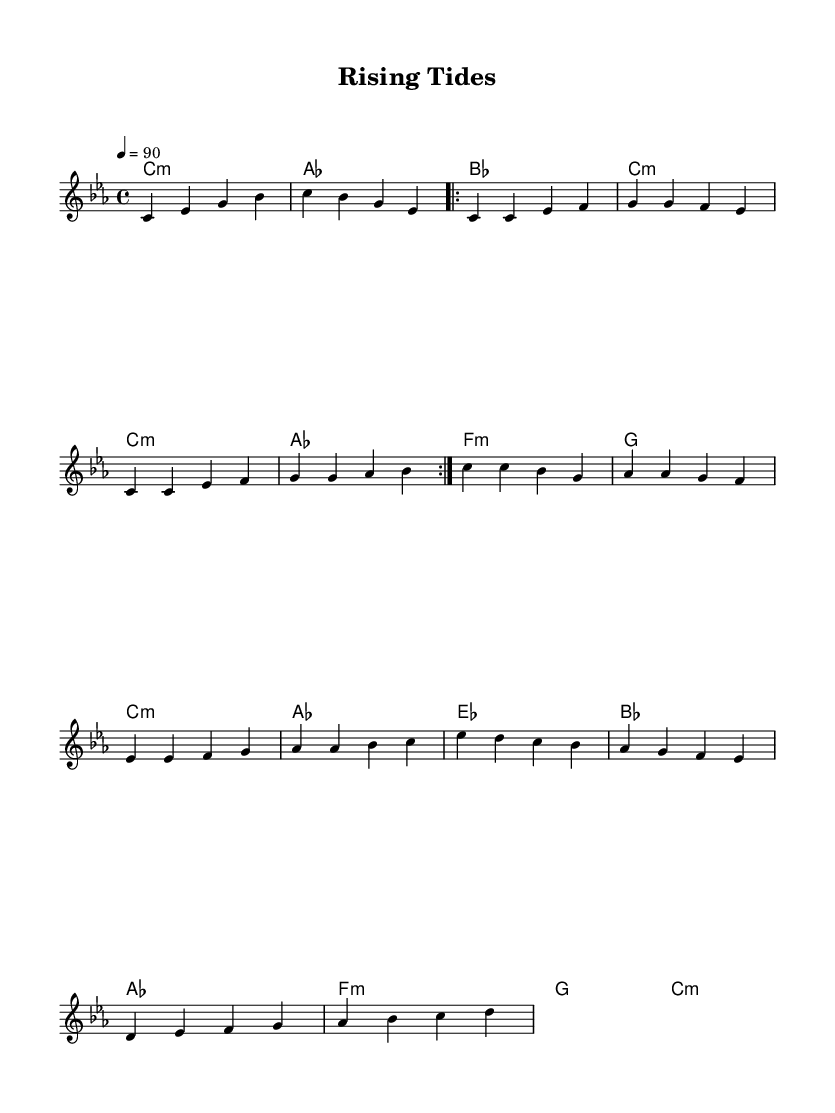What is the key signature of this music? The key signature is C minor, which consists of three flats (B flat, E flat, and A flat). This can be determined by looking at the beginning of the sheet music where the key signature symbol is noted.
Answer: C minor What is the time signature of this music? The time signature is 4/4, which indicates that there are four beats per measure, and a quarter note gets one beat. This is visually identifiable as the time signature is shown at the start of the music.
Answer: 4/4 What is the tempo marking for this piece? The tempo marking is 90 beats per minute, indicated by the tempo notation that specifies the speed of the piece. This gives performers an idea of how fast or slow to play the music.
Answer: 90 How many times is the verse repeated? The verse is repeated 2 times, as indicated by the repeat sign which denotes that the section should be played again. This can be found at the start of the verse section in the score.
Answer: 2 Which chord is played during the bridge? The chord played during the bridge is A flat major, mentioned in the chord progression section of the music. It is identified by the chord symbol appearing at the relevant points in the bridge section.
Answer: A flat major What is the structure of the piece? The structure of the piece consists of an Intro, Verse, Chorus, and Bridge, which can be inferred from the layout of the music and the naming of each section, indicating a common format found in rap songs.
Answer: Intro, Verse, Chorus, Bridge 